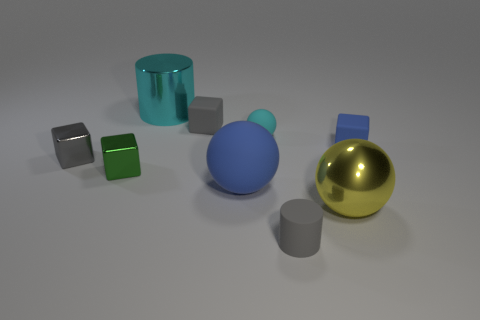Subtract 1 spheres. How many spheres are left? 2 Subtract all green cubes. How many cubes are left? 3 Subtract all cyan blocks. Subtract all purple spheres. How many blocks are left? 4 Subtract all blocks. How many objects are left? 5 Add 3 large blue matte spheres. How many large blue matte spheres exist? 4 Subtract 1 gray cylinders. How many objects are left? 8 Subtract all large red balls. Subtract all small green blocks. How many objects are left? 8 Add 7 rubber spheres. How many rubber spheres are left? 9 